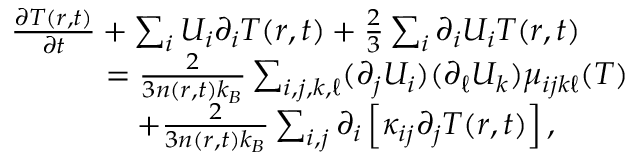<formula> <loc_0><loc_0><loc_500><loc_500>\begin{array} { r l } & { \frac { \partial T ( r , t ) } { \partial t } + \sum _ { i } U _ { i } \partial _ { i } T ( r , t ) + \frac { 2 } { 3 } \sum _ { i } \partial _ { i } U _ { i } T ( r , t ) } \\ & { \quad = \frac { 2 } { 3 n ( r , t ) k _ { B } } \sum _ { i , j , k , \ell } ( \partial _ { j } U _ { i } ) ( \partial _ { \ell } U _ { k } ) \mu _ { i j k \ell } ( T ) } \\ & { \quad + \frac { 2 } { 3 n ( r , t ) k _ { B } } \sum _ { i , j } \partial _ { i } \left [ \kappa _ { i j } \partial _ { j } T ( r , t ) \right ] , } \end{array}</formula> 